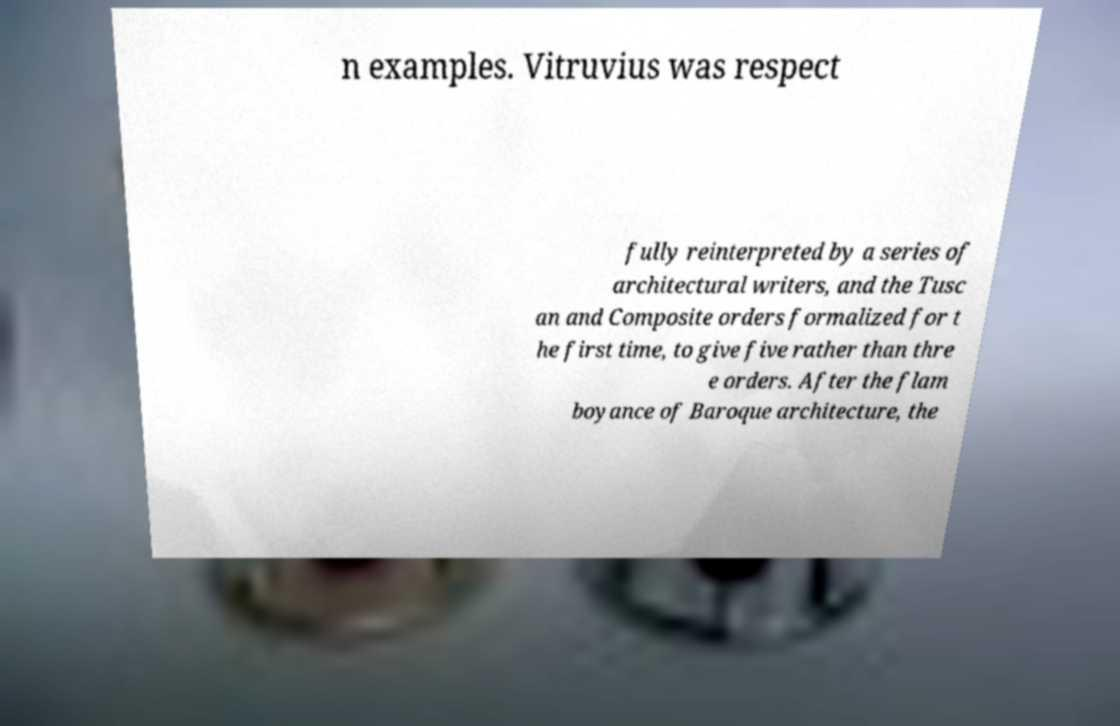Could you assist in decoding the text presented in this image and type it out clearly? n examples. Vitruvius was respect fully reinterpreted by a series of architectural writers, and the Tusc an and Composite orders formalized for t he first time, to give five rather than thre e orders. After the flam boyance of Baroque architecture, the 